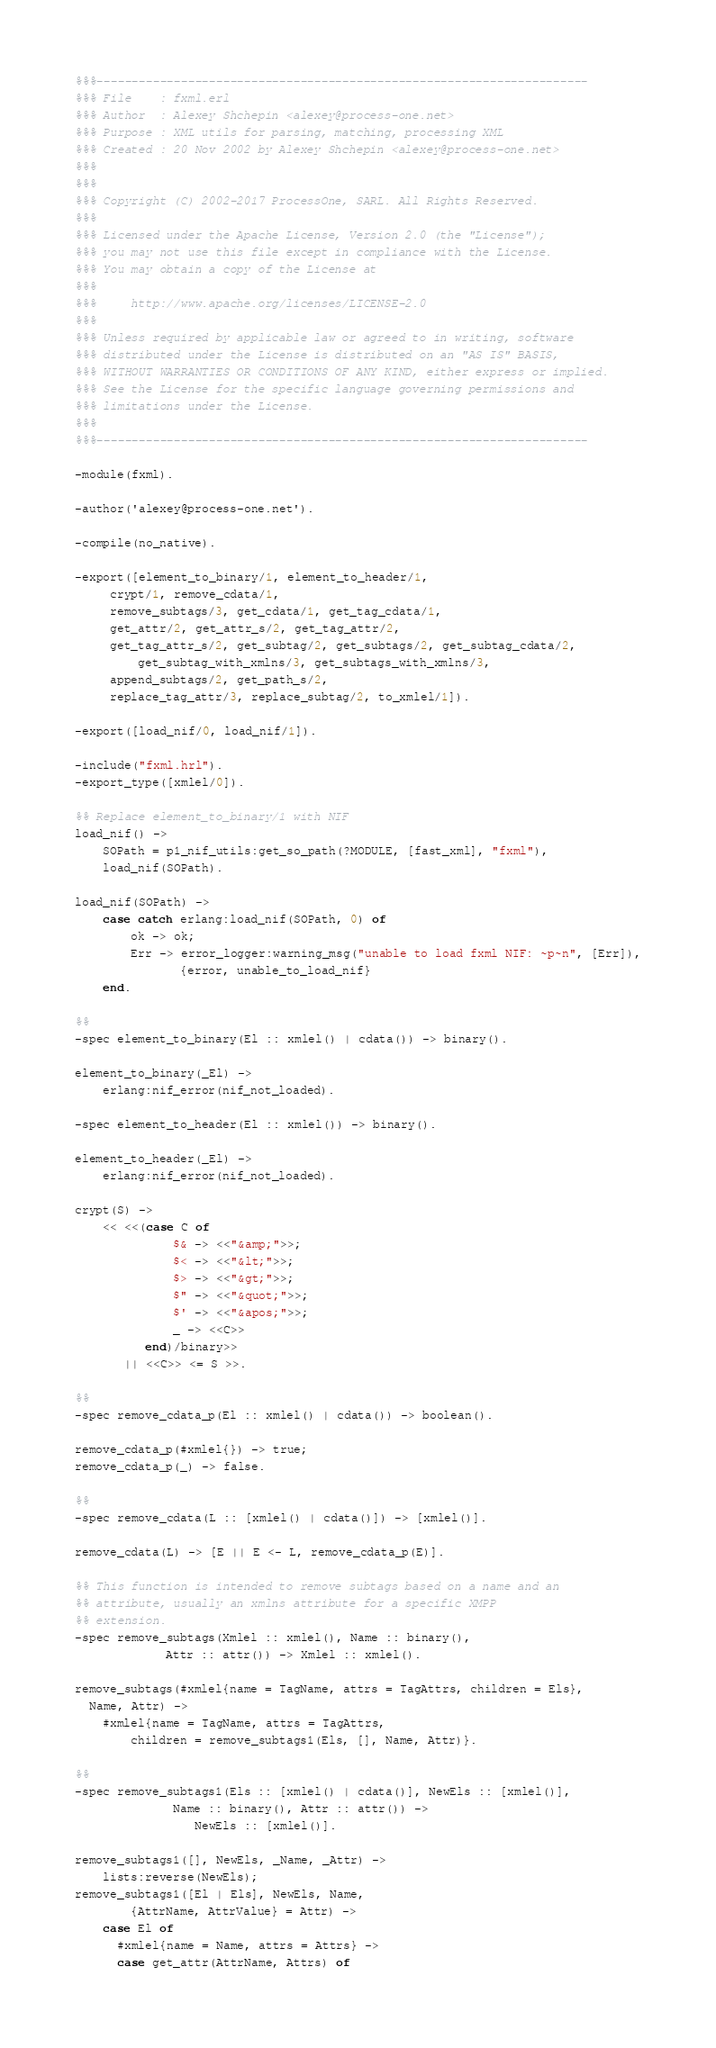Convert code to text. <code><loc_0><loc_0><loc_500><loc_500><_Erlang_>%%%----------------------------------------------------------------------
%%% File    : fxml.erl
%%% Author  : Alexey Shchepin <alexey@process-one.net>
%%% Purpose : XML utils for parsing, matching, processing XML
%%% Created : 20 Nov 2002 by Alexey Shchepin <alexey@process-one.net>
%%%
%%%
%%% Copyright (C) 2002-2017 ProcessOne, SARL. All Rights Reserved.
%%%
%%% Licensed under the Apache License, Version 2.0 (the "License");
%%% you may not use this file except in compliance with the License.
%%% You may obtain a copy of the License at
%%%
%%%     http://www.apache.org/licenses/LICENSE-2.0
%%%
%%% Unless required by applicable law or agreed to in writing, software
%%% distributed under the License is distributed on an "AS IS" BASIS,
%%% WITHOUT WARRANTIES OR CONDITIONS OF ANY KIND, either express or implied.
%%% See the License for the specific language governing permissions and
%%% limitations under the License.
%%%
%%%----------------------------------------------------------------------

-module(fxml).

-author('alexey@process-one.net').

-compile(no_native).

-export([element_to_binary/1, element_to_header/1,
	 crypt/1, remove_cdata/1,
	 remove_subtags/3, get_cdata/1, get_tag_cdata/1,
	 get_attr/2, get_attr_s/2, get_tag_attr/2,
	 get_tag_attr_s/2, get_subtag/2, get_subtags/2, get_subtag_cdata/2,
         get_subtag_with_xmlns/3, get_subtags_with_xmlns/3,
	 append_subtags/2, get_path_s/2,
	 replace_tag_attr/3, replace_subtag/2, to_xmlel/1]).

-export([load_nif/0, load_nif/1]).

-include("fxml.hrl").
-export_type([xmlel/0]).

%% Replace element_to_binary/1 with NIF
load_nif() ->
    SOPath = p1_nif_utils:get_so_path(?MODULE, [fast_xml], "fxml"),
    load_nif(SOPath).

load_nif(SOPath) ->
    case catch erlang:load_nif(SOPath, 0) of
        ok -> ok;
        Err -> error_logger:warning_msg("unable to load fxml NIF: ~p~n", [Err]),
               {error, unable_to_load_nif}
    end.

%%
-spec element_to_binary(El :: xmlel() | cdata()) -> binary().

element_to_binary(_El) ->
    erlang:nif_error(nif_not_loaded).

-spec element_to_header(El :: xmlel()) -> binary().

element_to_header(_El) ->
    erlang:nif_error(nif_not_loaded).

crypt(S) ->
    << <<(case C of
              $& -> <<"&amp;">>;
              $< -> <<"&lt;">>;
              $> -> <<"&gt;">>;
              $" -> <<"&quot;">>;
              $' -> <<"&apos;">>;
              _ -> <<C>>
          end)/binary>>
       || <<C>> <= S >>.

%%
-spec remove_cdata_p(El :: xmlel() | cdata()) -> boolean().

remove_cdata_p(#xmlel{}) -> true;
remove_cdata_p(_) -> false.

%%
-spec remove_cdata(L :: [xmlel() | cdata()]) -> [xmlel()].

remove_cdata(L) -> [E || E <- L, remove_cdata_p(E)].

%% This function is intended to remove subtags based on a name and an
%% attribute, usually an xmlns attribute for a specific XMPP
%% extension.
-spec remove_subtags(Xmlel :: xmlel(), Name :: binary(),
		     Attr :: attr()) -> Xmlel :: xmlel().

remove_subtags(#xmlel{name = TagName, attrs = TagAttrs, children = Els},
  Name, Attr) ->
    #xmlel{name = TagName, attrs = TagAttrs,
        children = remove_subtags1(Els, [], Name, Attr)}.

%%
-spec remove_subtags1(Els :: [xmlel() | cdata()], NewEls :: [xmlel()],
		      Name :: binary(), Attr :: attr()) ->
			     NewEls :: [xmlel()].

remove_subtags1([], NewEls, _Name, _Attr) ->
    lists:reverse(NewEls);
remove_subtags1([El | Els], NewEls, Name,
		{AttrName, AttrValue} = Attr) ->
    case El of
      #xmlel{name = Name, attrs = Attrs} ->
	  case get_attr(AttrName, Attrs) of</code> 